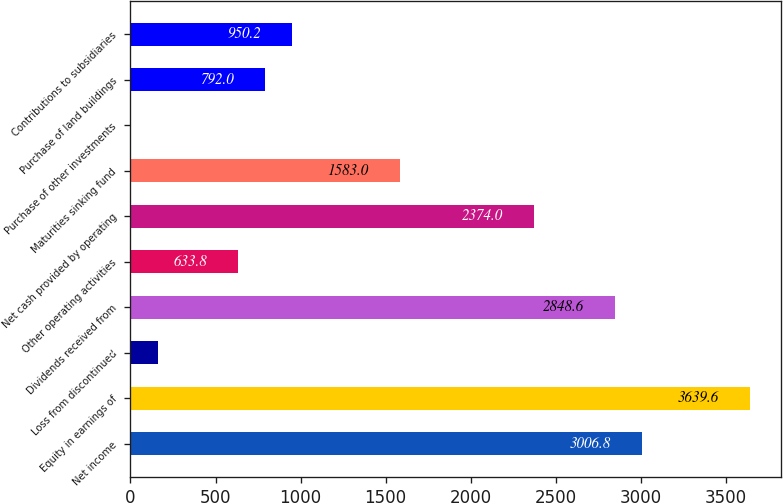<chart> <loc_0><loc_0><loc_500><loc_500><bar_chart><fcel>Net income<fcel>Equity in earnings of<fcel>Loss from discontinued<fcel>Dividends received from<fcel>Other operating activities<fcel>Net cash provided by operating<fcel>Maturities sinking fund<fcel>Purchase of other investments<fcel>Purchase of land buildings<fcel>Contributions to subsidiaries<nl><fcel>3006.8<fcel>3639.6<fcel>159.2<fcel>2848.6<fcel>633.8<fcel>2374<fcel>1583<fcel>1<fcel>792<fcel>950.2<nl></chart> 